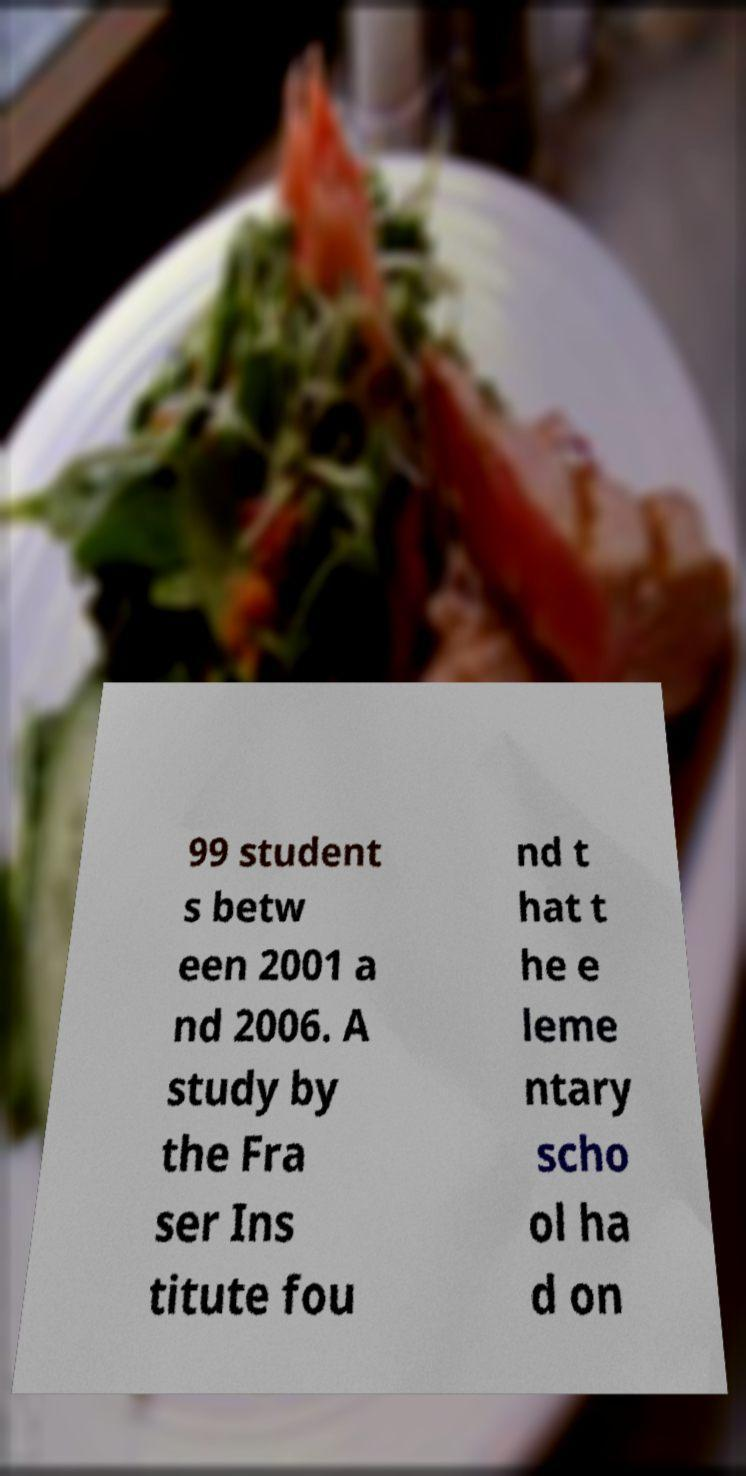What messages or text are displayed in this image? I need them in a readable, typed format. 99 student s betw een 2001 a nd 2006. A study by the Fra ser Ins titute fou nd t hat t he e leme ntary scho ol ha d on 